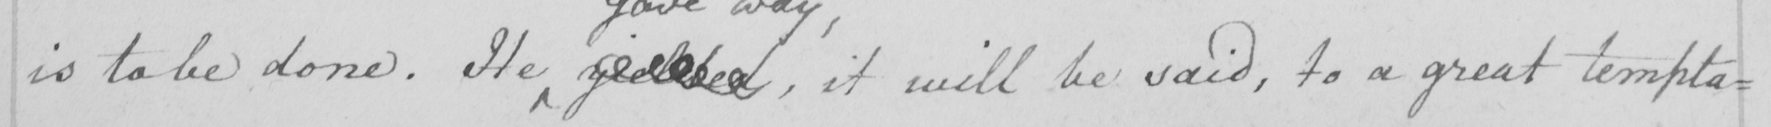Please provide the text content of this handwritten line. is to be done . He yielded , it will be said , to a great tempta= 